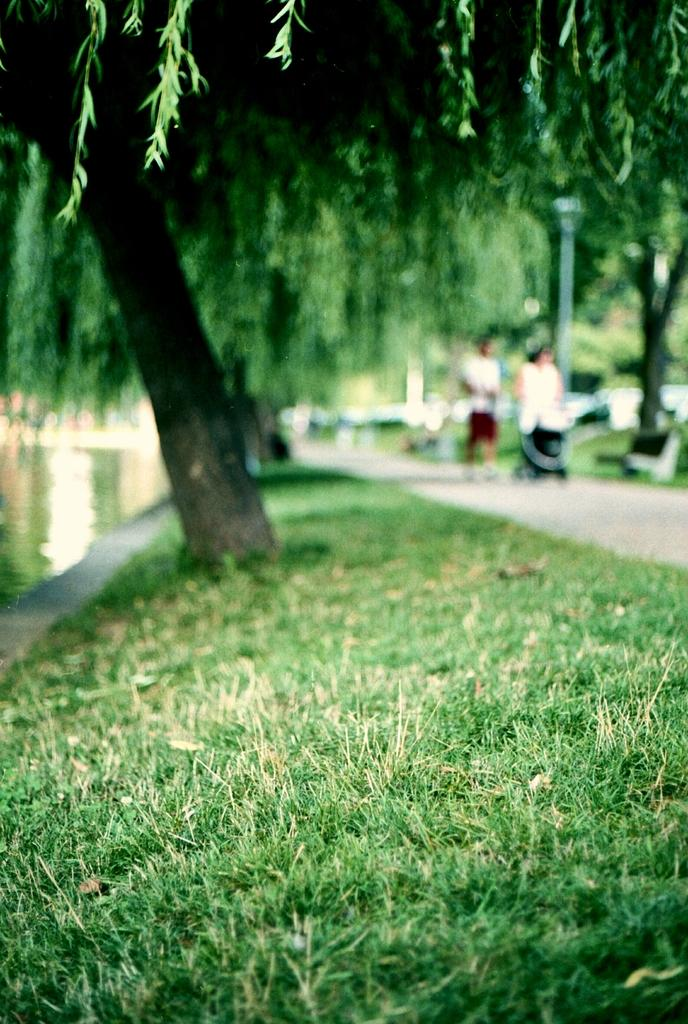What type of vegetation is present in the image? There is grass in the image. What can be seen behind the grass? There is a huge tree behind the grass. How is the background of the tree depicted in the image? The background of the tree is blurred. What time does the clock on the tree show in the image? There is no clock present on the tree in the image. 